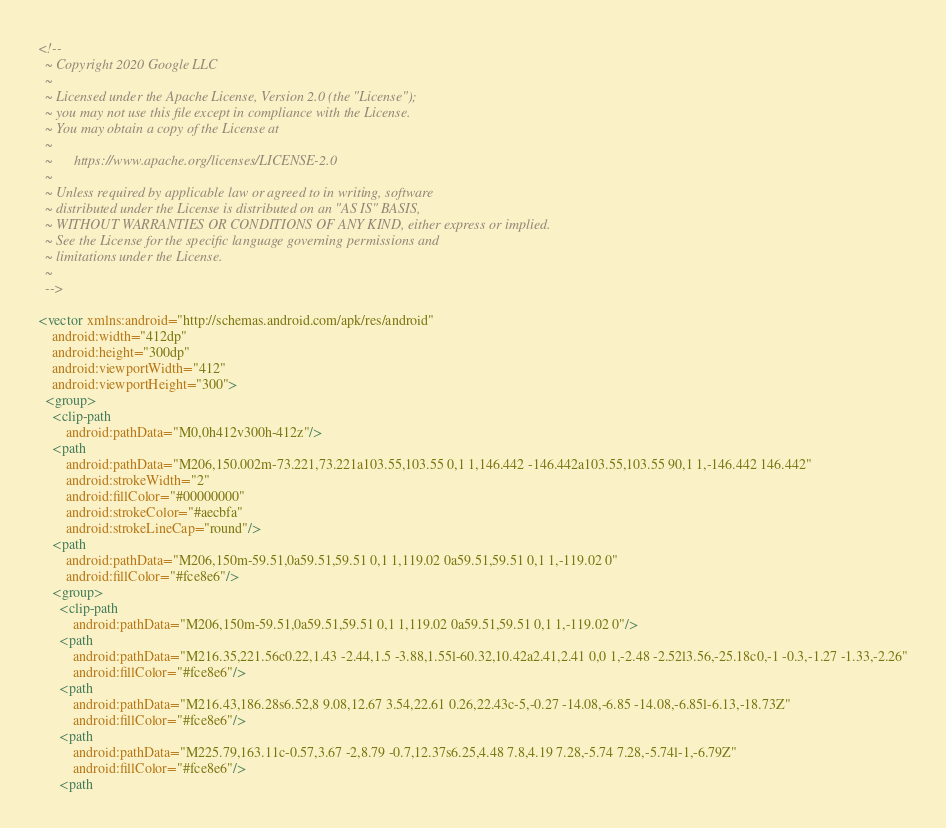<code> <loc_0><loc_0><loc_500><loc_500><_XML_><!--
  ~ Copyright 2020 Google LLC
  ~
  ~ Licensed under the Apache License, Version 2.0 (the "License");
  ~ you may not use this file except in compliance with the License.
  ~ You may obtain a copy of the License at
  ~
  ~      https://www.apache.org/licenses/LICENSE-2.0
  ~
  ~ Unless required by applicable law or agreed to in writing, software
  ~ distributed under the License is distributed on an "AS IS" BASIS,
  ~ WITHOUT WARRANTIES OR CONDITIONS OF ANY KIND, either express or implied.
  ~ See the License for the specific language governing permissions and
  ~ limitations under the License.
  ~
  -->

<vector xmlns:android="http://schemas.android.com/apk/res/android"
    android:width="412dp"
    android:height="300dp"
    android:viewportWidth="412"
    android:viewportHeight="300">
  <group>
    <clip-path
        android:pathData="M0,0h412v300h-412z"/>
    <path
        android:pathData="M206,150.002m-73.221,73.221a103.55,103.55 0,1 1,146.442 -146.442a103.55,103.55 90,1 1,-146.442 146.442"
        android:strokeWidth="2"
        android:fillColor="#00000000"
        android:strokeColor="#aecbfa"
        android:strokeLineCap="round"/>
    <path
        android:pathData="M206,150m-59.51,0a59.51,59.51 0,1 1,119.02 0a59.51,59.51 0,1 1,-119.02 0"
        android:fillColor="#fce8e6"/>
    <group>
      <clip-path
          android:pathData="M206,150m-59.51,0a59.51,59.51 0,1 1,119.02 0a59.51,59.51 0,1 1,-119.02 0"/>
      <path
          android:pathData="M216.35,221.56c0.22,1.43 -2.44,1.5 -3.88,1.55l-60.32,10.42a2.41,2.41 0,0 1,-2.48 -2.52l3.56,-25.18c0,-1 -0.3,-1.27 -1.33,-2.26"
          android:fillColor="#fce8e6"/>
      <path
          android:pathData="M216.43,186.28s6.52,8 9.08,12.67 3.54,22.61 0.26,22.43c-5,-0.27 -14.08,-6.85 -14.08,-6.85l-6.13,-18.73Z"
          android:fillColor="#fce8e6"/>
      <path
          android:pathData="M225.79,163.11c-0.57,3.67 -2,8.79 -0.7,12.37s6.25,4.48 7.8,4.19 7.28,-5.74 7.28,-5.74l-1,-6.79Z"
          android:fillColor="#fce8e6"/>
      <path</code> 